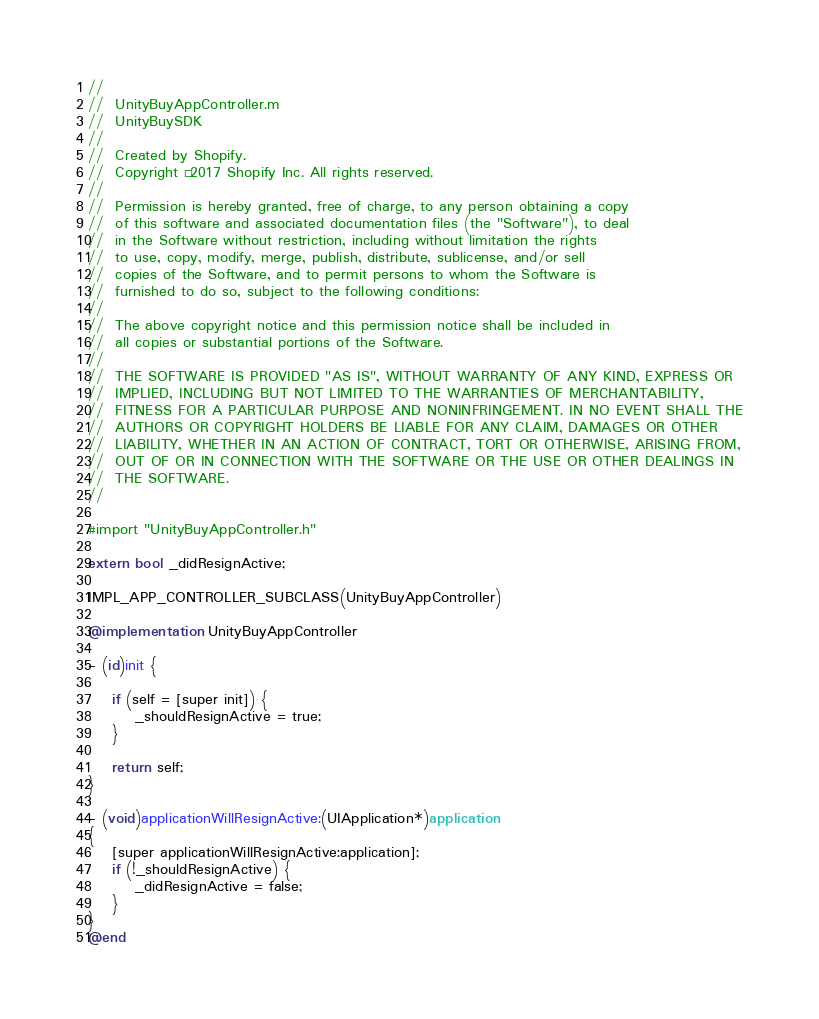<code> <loc_0><loc_0><loc_500><loc_500><_ObjectiveC_>//
//  UnityBuyAppController.m
//  UnityBuySDK
//
//  Created by Shopify.
//  Copyright © 2017 Shopify Inc. All rights reserved.
//
//  Permission is hereby granted, free of charge, to any person obtaining a copy
//  of this software and associated documentation files (the "Software"), to deal
//  in the Software without restriction, including without limitation the rights
//  to use, copy, modify, merge, publish, distribute, sublicense, and/or sell
//  copies of the Software, and to permit persons to whom the Software is
//  furnished to do so, subject to the following conditions:
//
//  The above copyright notice and this permission notice shall be included in
//  all copies or substantial portions of the Software.
//
//  THE SOFTWARE IS PROVIDED "AS IS", WITHOUT WARRANTY OF ANY KIND, EXPRESS OR
//  IMPLIED, INCLUDING BUT NOT LIMITED TO THE WARRANTIES OF MERCHANTABILITY,
//  FITNESS FOR A PARTICULAR PURPOSE AND NONINFRINGEMENT. IN NO EVENT SHALL THE
//  AUTHORS OR COPYRIGHT HOLDERS BE LIABLE FOR ANY CLAIM, DAMAGES OR OTHER
//  LIABILITY, WHETHER IN AN ACTION OF CONTRACT, TORT OR OTHERWISE, ARISING FROM,
//  OUT OF OR IN CONNECTION WITH THE SOFTWARE OR THE USE OR OTHER DEALINGS IN
//  THE SOFTWARE.
//

#import "UnityBuyAppController.h"

extern bool _didResignActive;

IMPL_APP_CONTROLLER_SUBCLASS(UnityBuyAppController)

@implementation UnityBuyAppController

- (id)init {
    
    if (self = [super init]) {
        _shouldResignActive = true;
    }
    
    return self;
}

- (void)applicationWillResignActive:(UIApplication*)application
{
    [super applicationWillResignActive:application];
    if (!_shouldResignActive) {
        _didResignActive = false;
    }
}
@end
</code> 